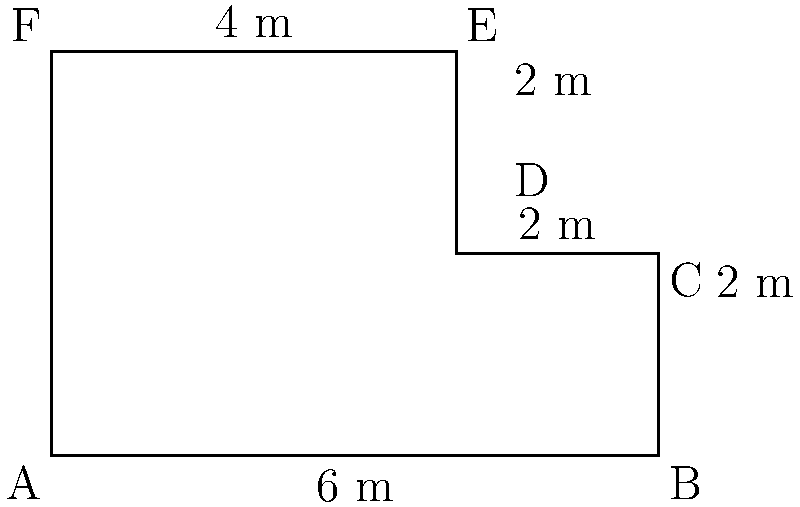As an insurance adjuster, you're assessing a damaged fence line represented by the composite shape ABCDEF. Calculate the perimeter of this fence line to determine the total length of fencing that needs to be replaced. To calculate the perimeter of the composite shape ABCDEF, we need to sum up the lengths of all sides:

1. Side AB: 6 m
2. Side BC: 2 m
3. Side CD: 2 m
4. Side DE: 2 m
5. Side EF: 4 m
6. Side FA: 4 m (same as the height of the shape)

Now, let's add up all these lengths:

$$ \text{Perimeter} = 6 + 2 + 2 + 2 + 4 + 4 = 20 \text{ m} $$

Therefore, the total length of fencing that needs to be replaced is 20 meters.
Answer: 20 m 